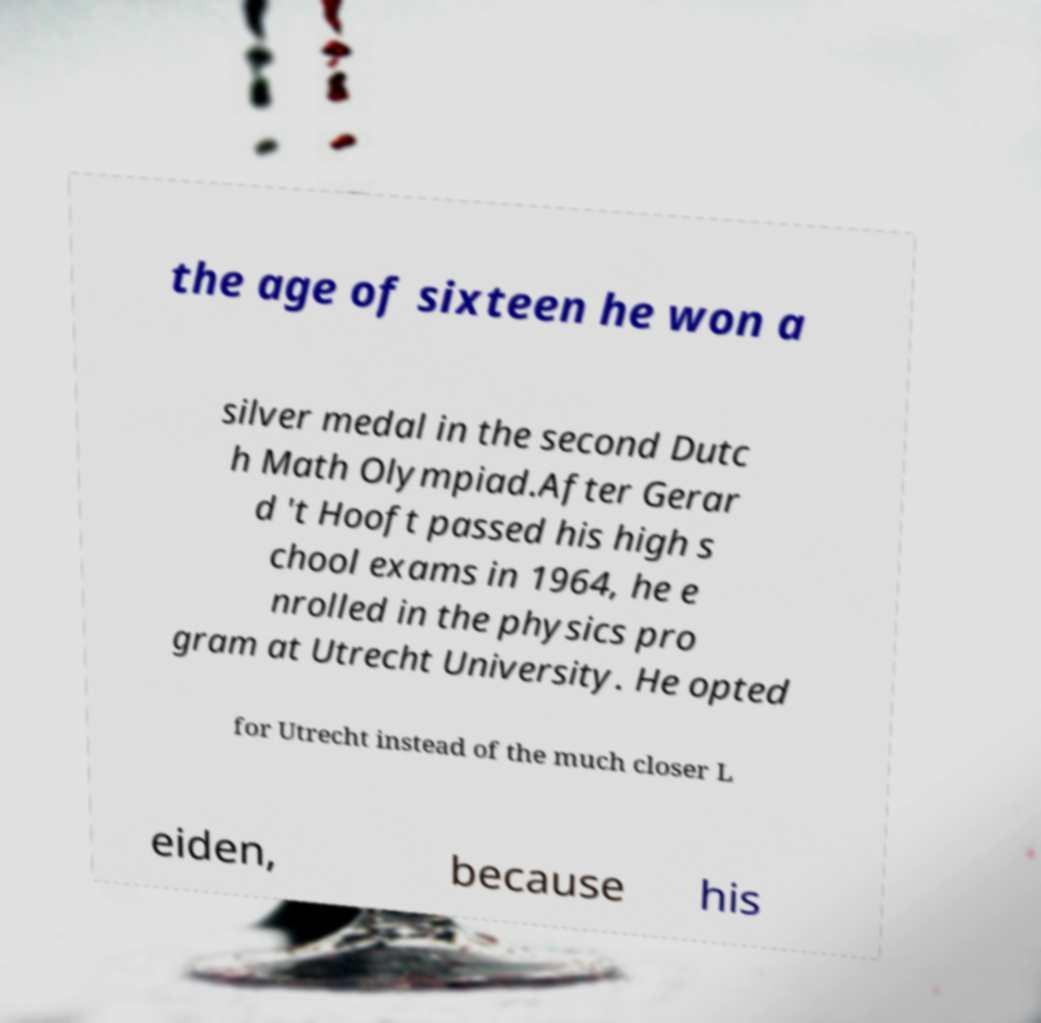Can you accurately transcribe the text from the provided image for me? the age of sixteen he won a silver medal in the second Dutc h Math Olympiad.After Gerar d 't Hooft passed his high s chool exams in 1964, he e nrolled in the physics pro gram at Utrecht University. He opted for Utrecht instead of the much closer L eiden, because his 